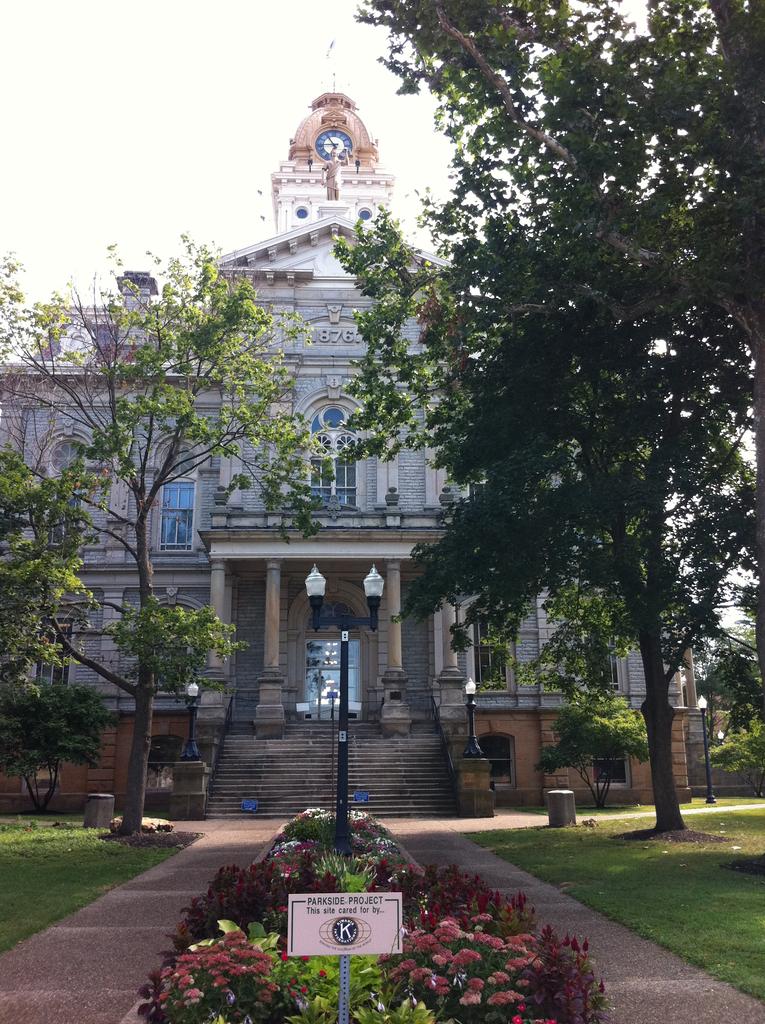What is the building used for?
Provide a short and direct response. Unanswerable. 